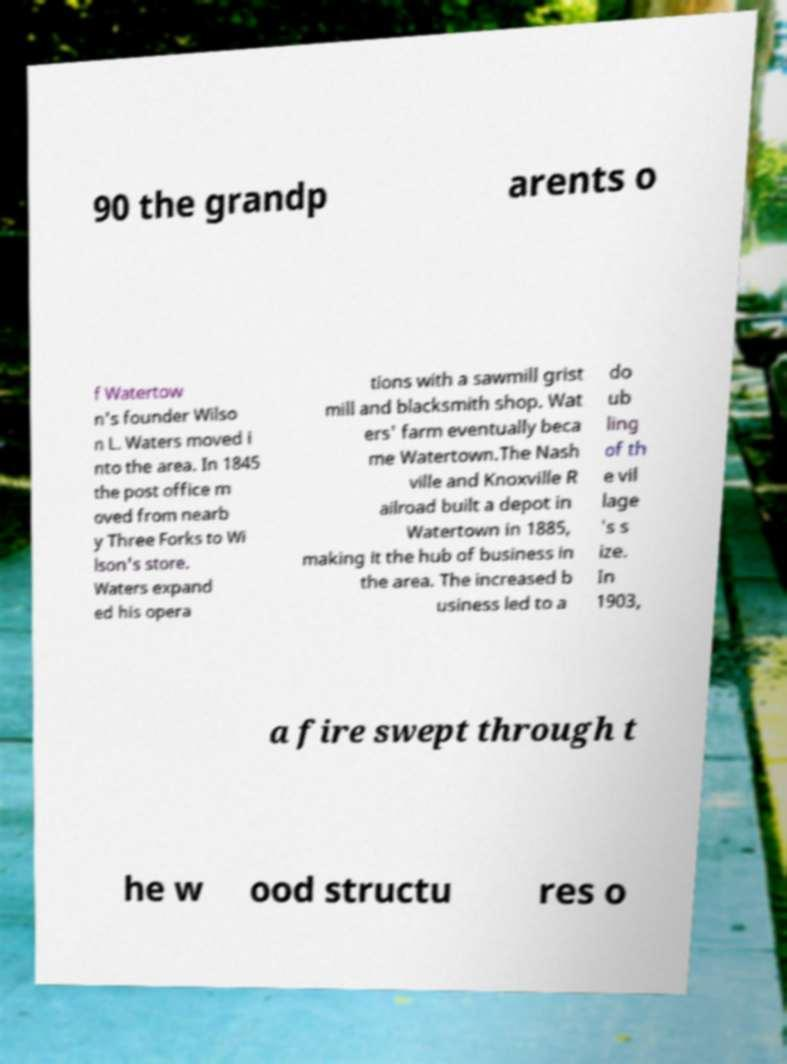I need the written content from this picture converted into text. Can you do that? 90 the grandp arents o f Watertow n's founder Wilso n L. Waters moved i nto the area. In 1845 the post office m oved from nearb y Three Forks to Wi lson's store. Waters expand ed his opera tions with a sawmill grist mill and blacksmith shop. Wat ers' farm eventually beca me Watertown.The Nash ville and Knoxville R ailroad built a depot in Watertown in 1885, making it the hub of business in the area. The increased b usiness led to a do ub ling of th e vil lage 's s ize. In 1903, a fire swept through t he w ood structu res o 